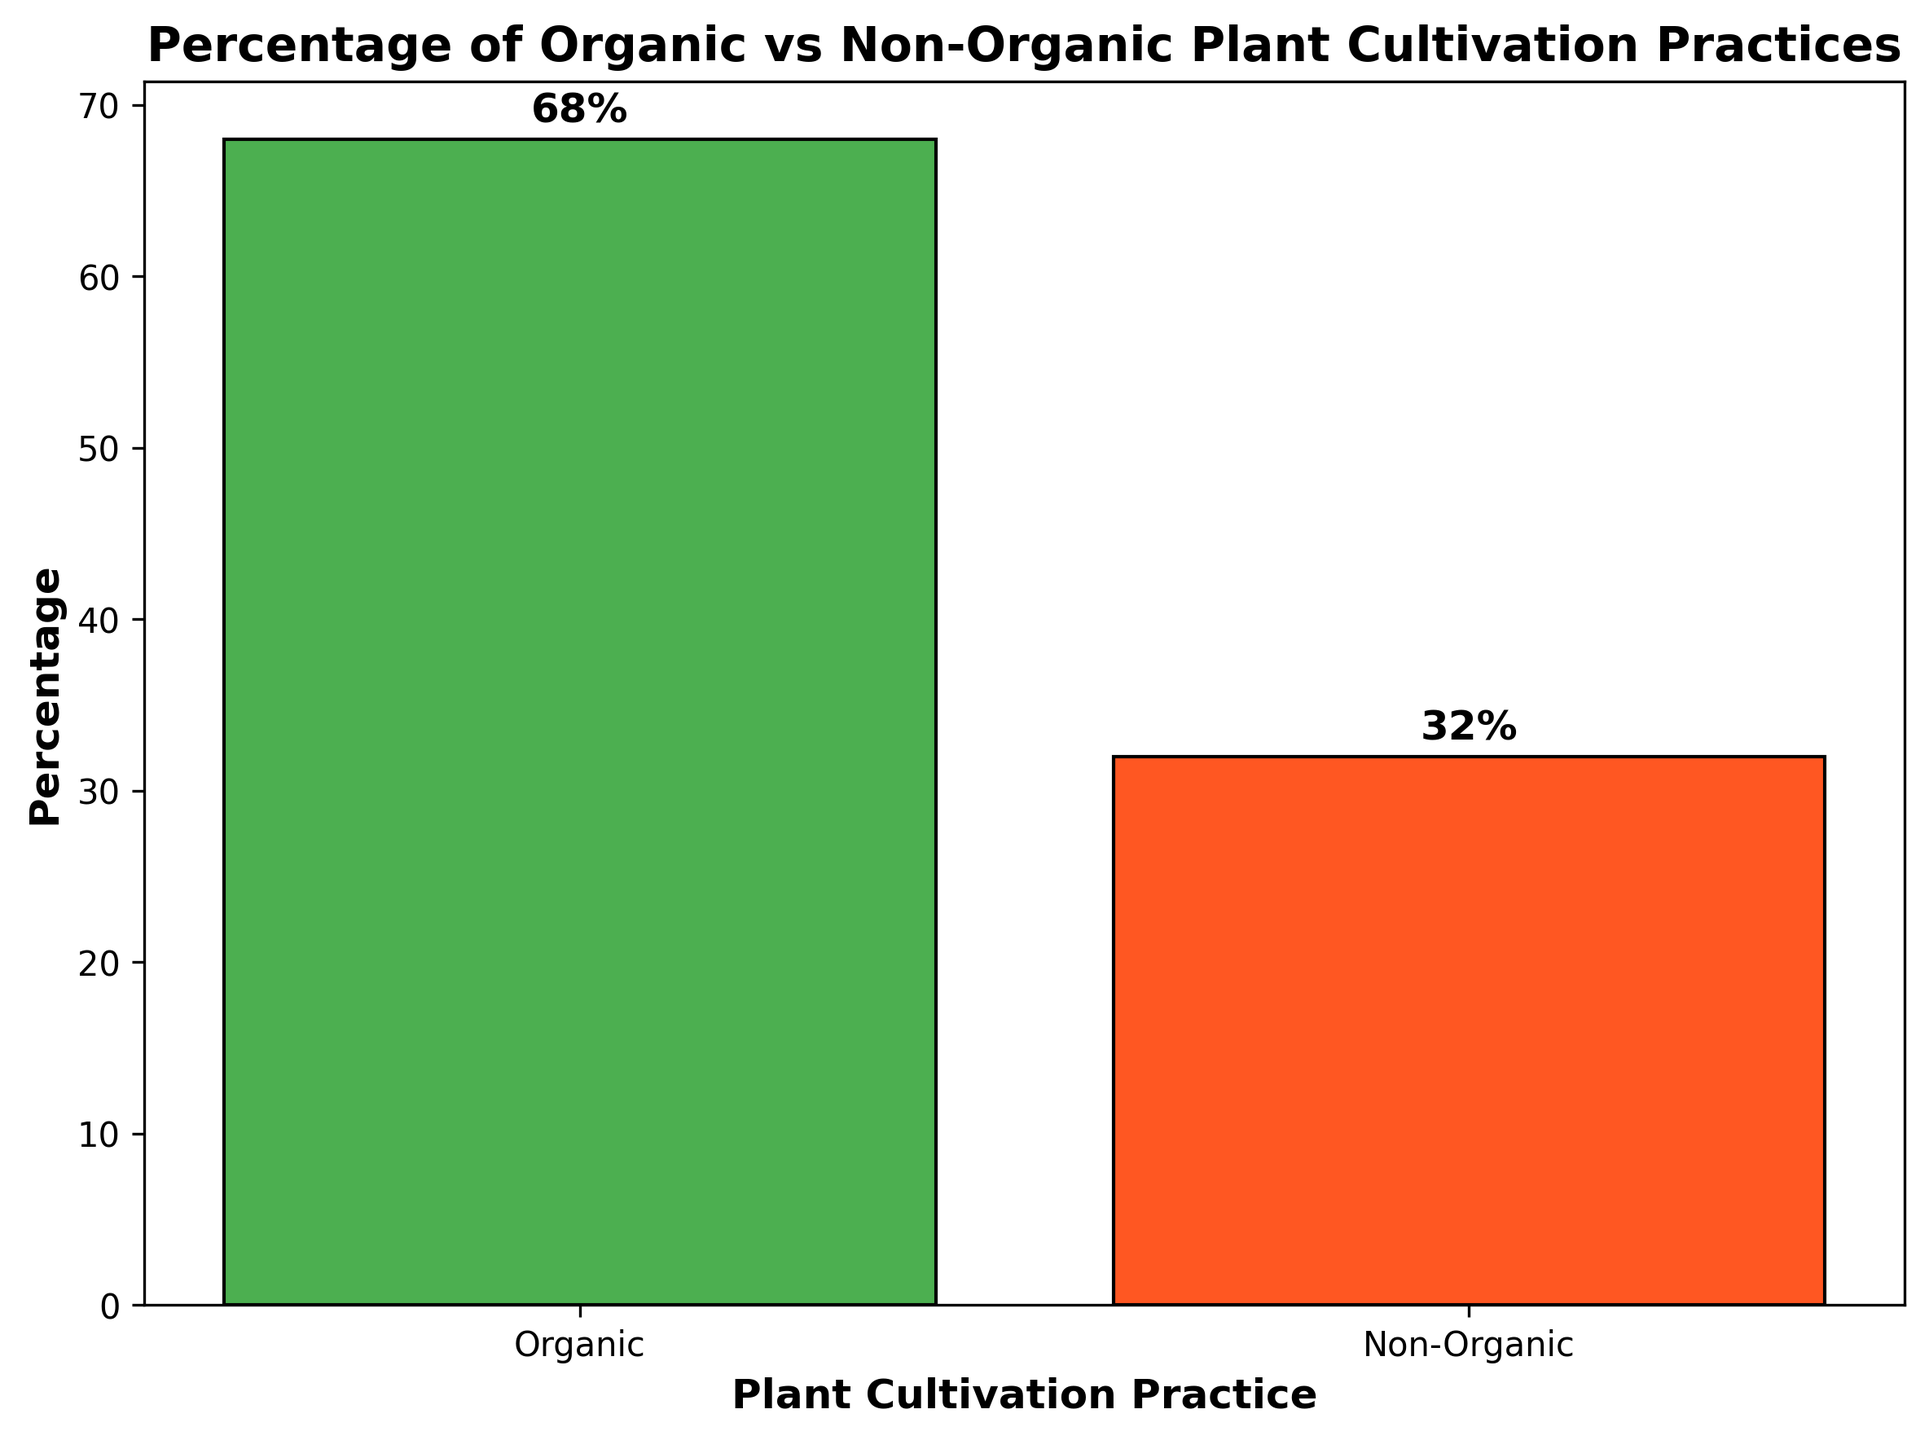Which plant cultivation practice is more common? The bar chart shows two plant cultivation practices: Organic and Non-Organic. The Organic bar is visibly taller than the Non-Organic bar.
Answer: Organic What is the percentage of Non-Organic plant cultivation practices? The number labeled on the Non-Organic bar displays the percentage, which is 32%.
Answer: 32% What is the percentage difference between Organic and Non-Organic practices? The percentage for Organic is 68%, and for Non-Organic, it is 32%. The difference is 68% - 32%.
Answer: 36% Which color represents Organic plant cultivation practices in the bar chart? Observing the bars, Organic is represented by a green bar.
Answer: Green How many times greater is the percentage of Organic than Non-Organic plant cultivation practices? Organic is 68%, and Non-Organic is 32%. Dividing the Organic percentage by the Non-Organic percentage gives us 68 / 32 = 2.125.
Answer: 2.125 times By how much does the percentage of Organic plant cultivation exceed half of the total cultivation? The total percentage is 100%. Half of the total is 50%. Organic percentage is 68%. The exceed amount is 68% - 50%.
Answer: 18% What is the combined percentage of both plant cultivation practices? Sum of percentages: Organic (68%) + Non-Organic (32%) = 68% + 32%
Answer: 100% Which bar is taller, the one representing Organic or Non-Organic? By visually comparing the heights, the Organic bar is taller than the Non-Organic bar.
Answer: Organic If you were to recommend a plant cultivation practice based on popularity, which one would you choose? Since the Organic practice has a higher percentage (68%) compared to Non-Organic (32%), it would be recommended based on popularity.
Answer: Organic 